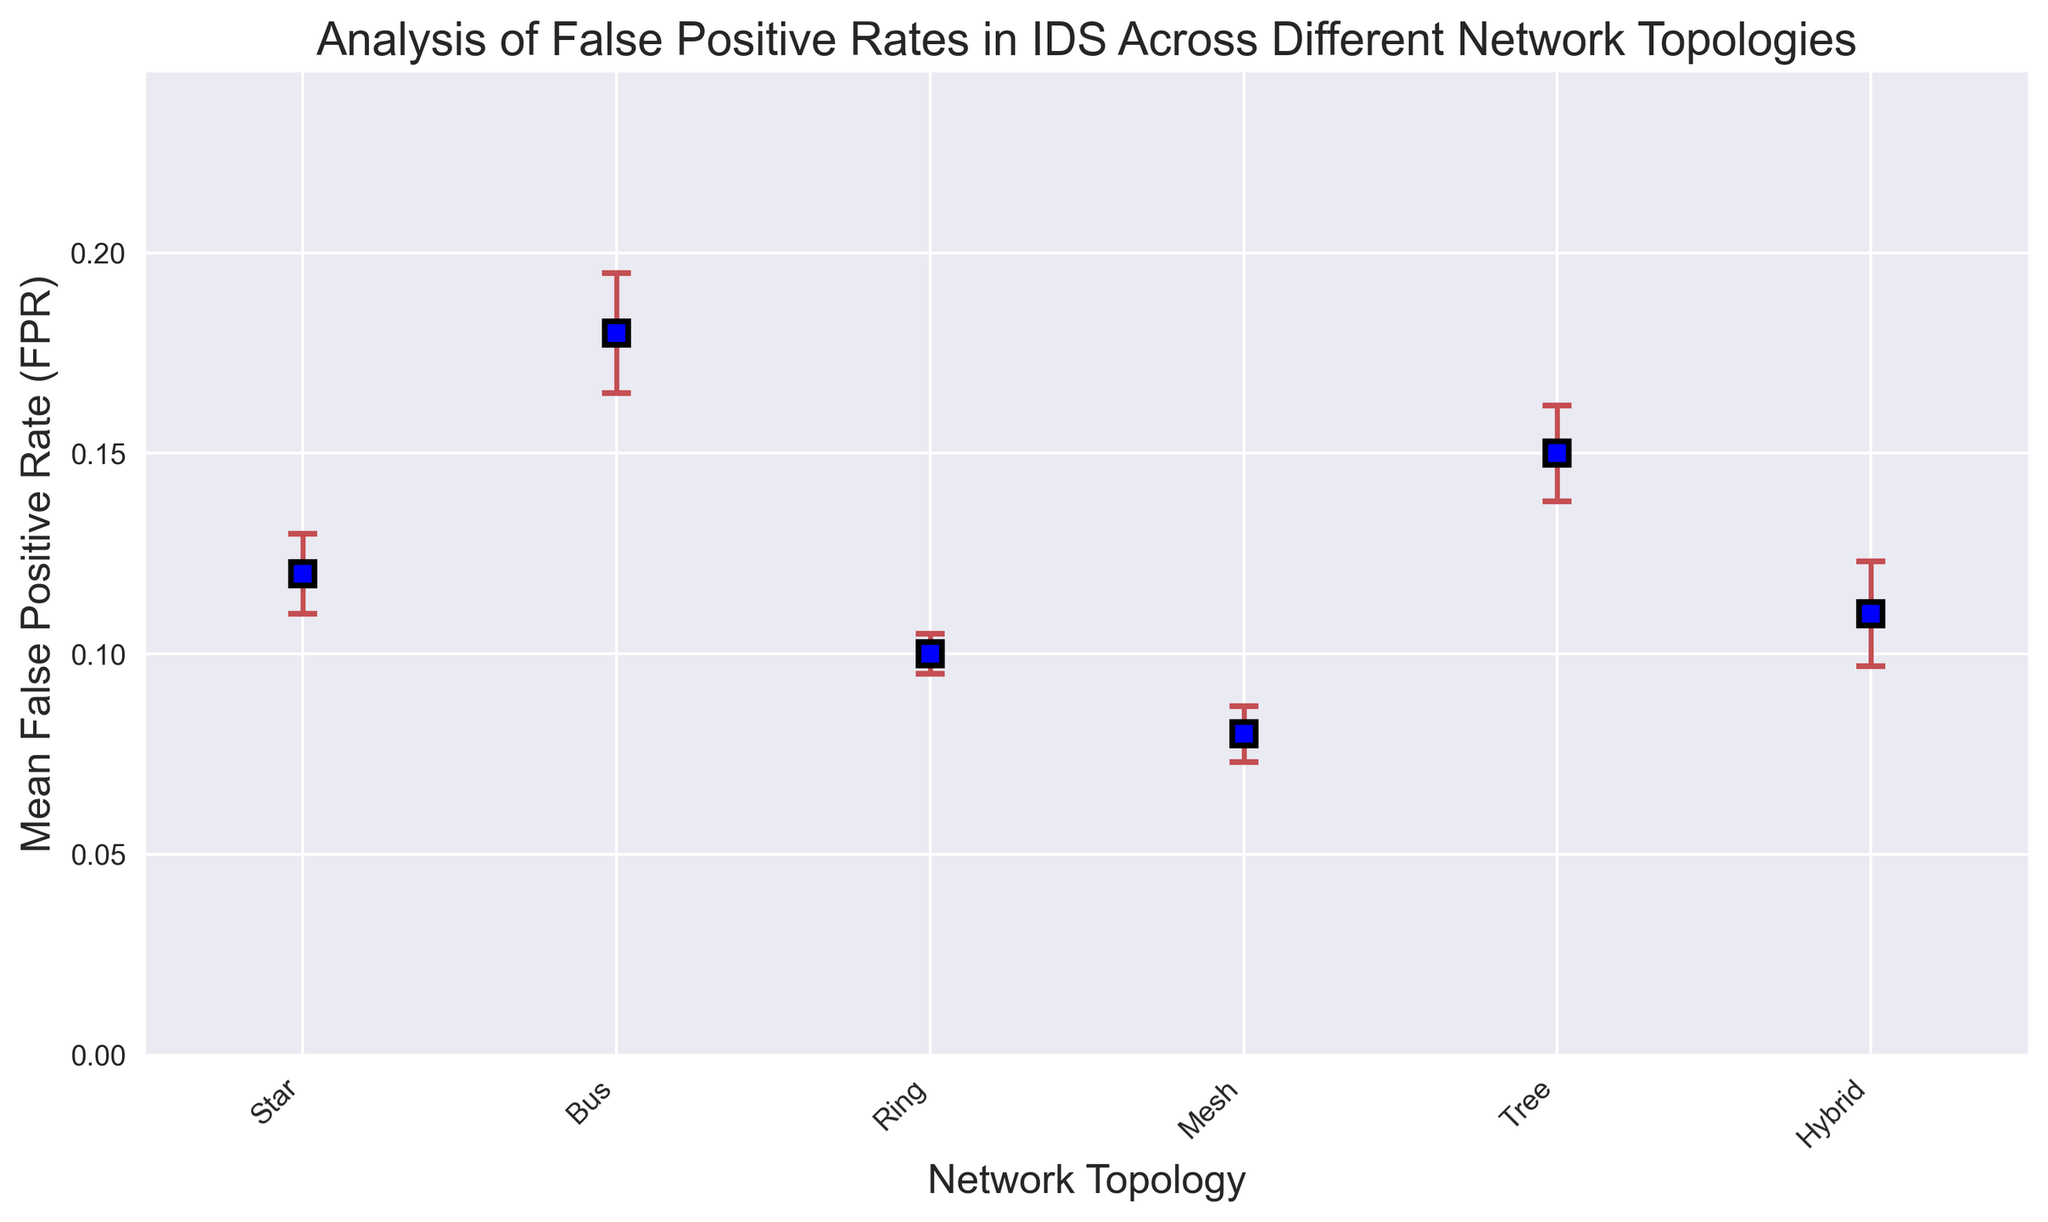What's the topology with the highest Mean FPR? The topology with the highest Mean FPR is the one with the tallest marker on the y-axis. By looking at the plot, we see that Bus topology has the highest value of Mean FPR.
Answer: Bus Which topology has the lowest Mean FPR? The topology with the lowest Mean FPR is the one with the shortest marker on the y-axis. Mesh topology has the lowest value of Mean FPR based on the figure.
Answer: Mesh Comparing Star and Ring topologies, which one has a higher Mean FPR, and by how much? Star topology has a Mean FPR of 0.12 while Ring topology has a Mean FPR of 0.1. The difference between them is 0.12 - 0.1 = 0.02.
Answer: Star, 0.02 What's the Mean FPR range for the topologies? The range can be determined by finding the difference between the highest and lowest Mean FPR values shown in the plot. The highest is 0.18 (Bus) and the lowest is 0.08 (Mesh). So, the range is 0.18 - 0.08 = 0.10.
Answer: 0.10 Which topology has the widest uncertainty (highest Std Deviation)? The topology with the longest error bar or the largest value in the yerr component has the highest uncertainty. This figure shows that Bus topology has the highest Std Deviation of 0.015.
Answer: Bus What is the total Mean FPR if you sum all topologies? Summing the Mean FPR values: 0.12 (Star) + 0.18 (Bus) + 0.1 (Ring) + 0.08 (Mesh) + 0.15 (Tree) + 0.11 (Hybrid). The total is 0.12 + 0.18 + 0.1 + 0.08 + 0.15 + 0.11 = 0.74.
Answer: 0.74 Which topologies have a Mean FPR greater than 0.1? The topologies with a Mean FPR greater than 0.1 are those where the marker is above the 0.1 mark on the y-axis. This is true for Star, Bus, Tree, and Hybrid topologies.
Answer: Star, Bus, Tree, Hybrid By how much does the Mean FPR of Tree topology exceed that of Ring topology? Tree topology has a Mean FPR of 0.15, and Ring topology has a Mean FPR of 0.1. The difference is 0.15 - 0.1 = 0.05.
Answer: 0.05 What is the average Mean FPR across all topologies? The average Mean FPR is computed by summing all the Mean FPR values and then dividing by the number of topologies. Sum of Mean FPRs is 0.74 and there are 6 topologies, hence the average is 0.74 / 6 ≈ 0.123.
Answer: 0.123 Considering the error bars, which topology has the largest upper error bar value for Mean FPR? The largest upper error bar corresponds to Bus topology since its Mean FPR plus Std Deviation (0.18 + 0.015) gives 0.195, which is greater than the others.
Answer: Bus 